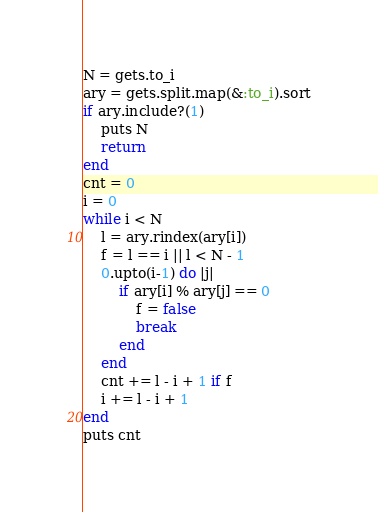Convert code to text. <code><loc_0><loc_0><loc_500><loc_500><_Ruby_>N = gets.to_i
ary = gets.split.map(&:to_i).sort
if ary.include?(1)
    puts N
    return
end
cnt = 0
i = 0
while i < N
    l = ary.rindex(ary[i])
    f = l == i || l < N - 1
    0.upto(i-1) do |j|
        if ary[i] % ary[j] == 0
            f = false
            break
        end
    end
    cnt += l - i + 1 if f
    i += l - i + 1
end
puts cnt</code> 